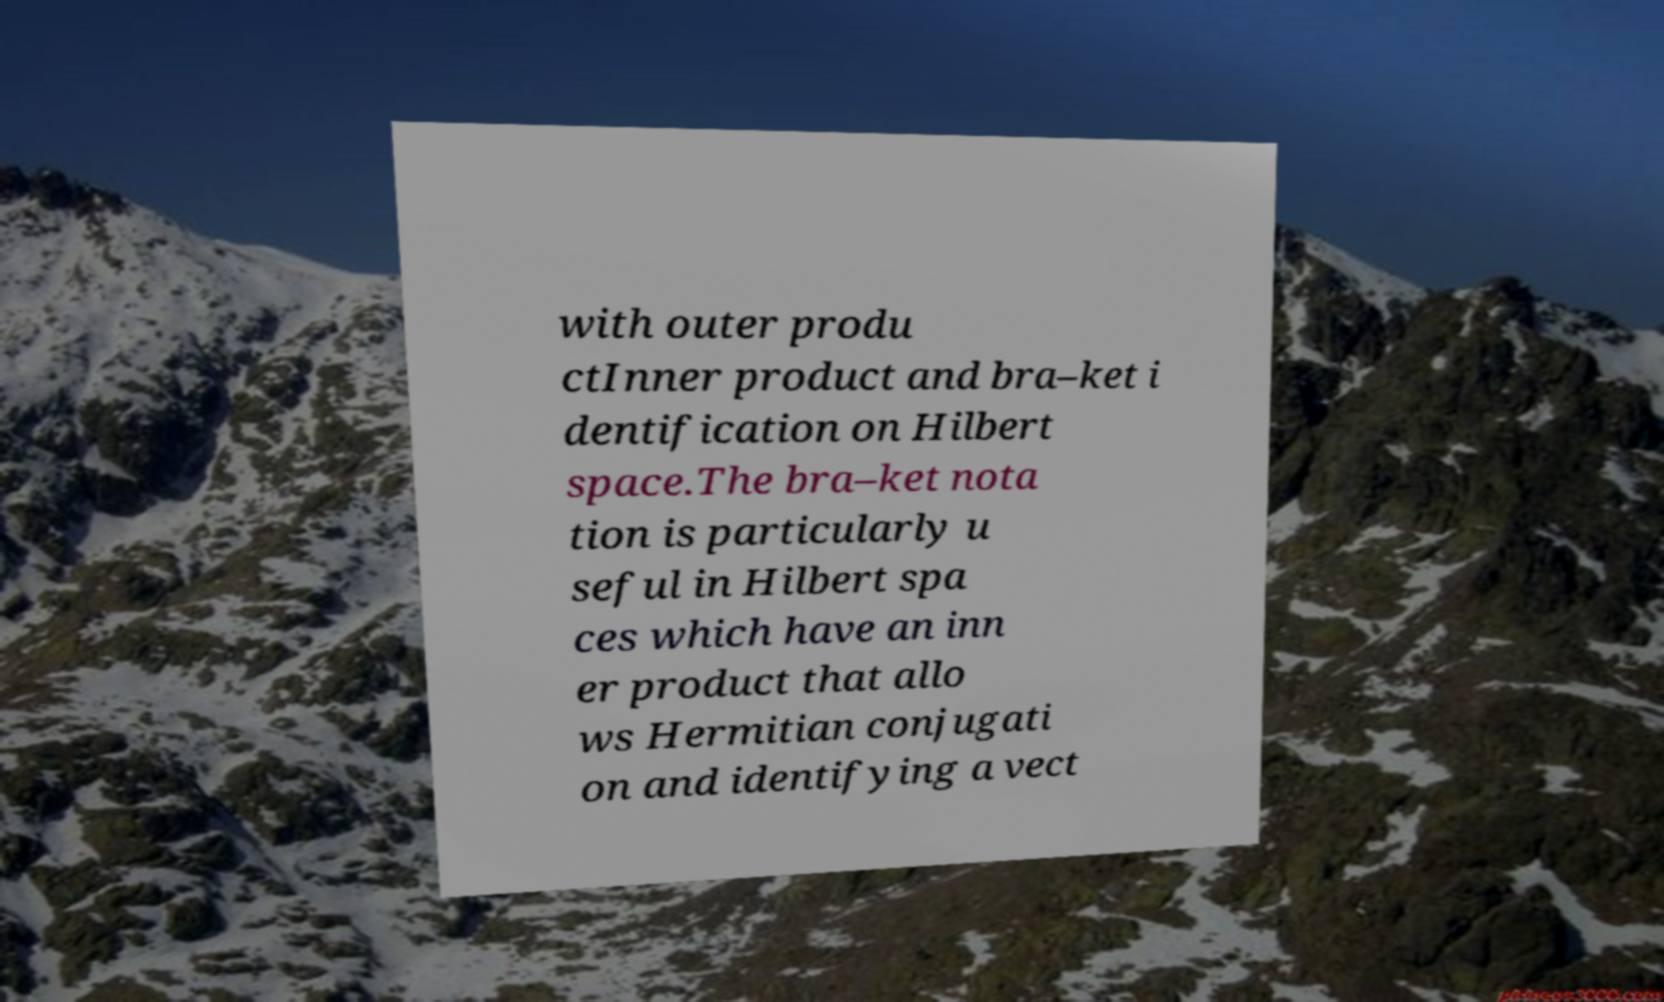Can you accurately transcribe the text from the provided image for me? with outer produ ctInner product and bra–ket i dentification on Hilbert space.The bra–ket nota tion is particularly u seful in Hilbert spa ces which have an inn er product that allo ws Hermitian conjugati on and identifying a vect 